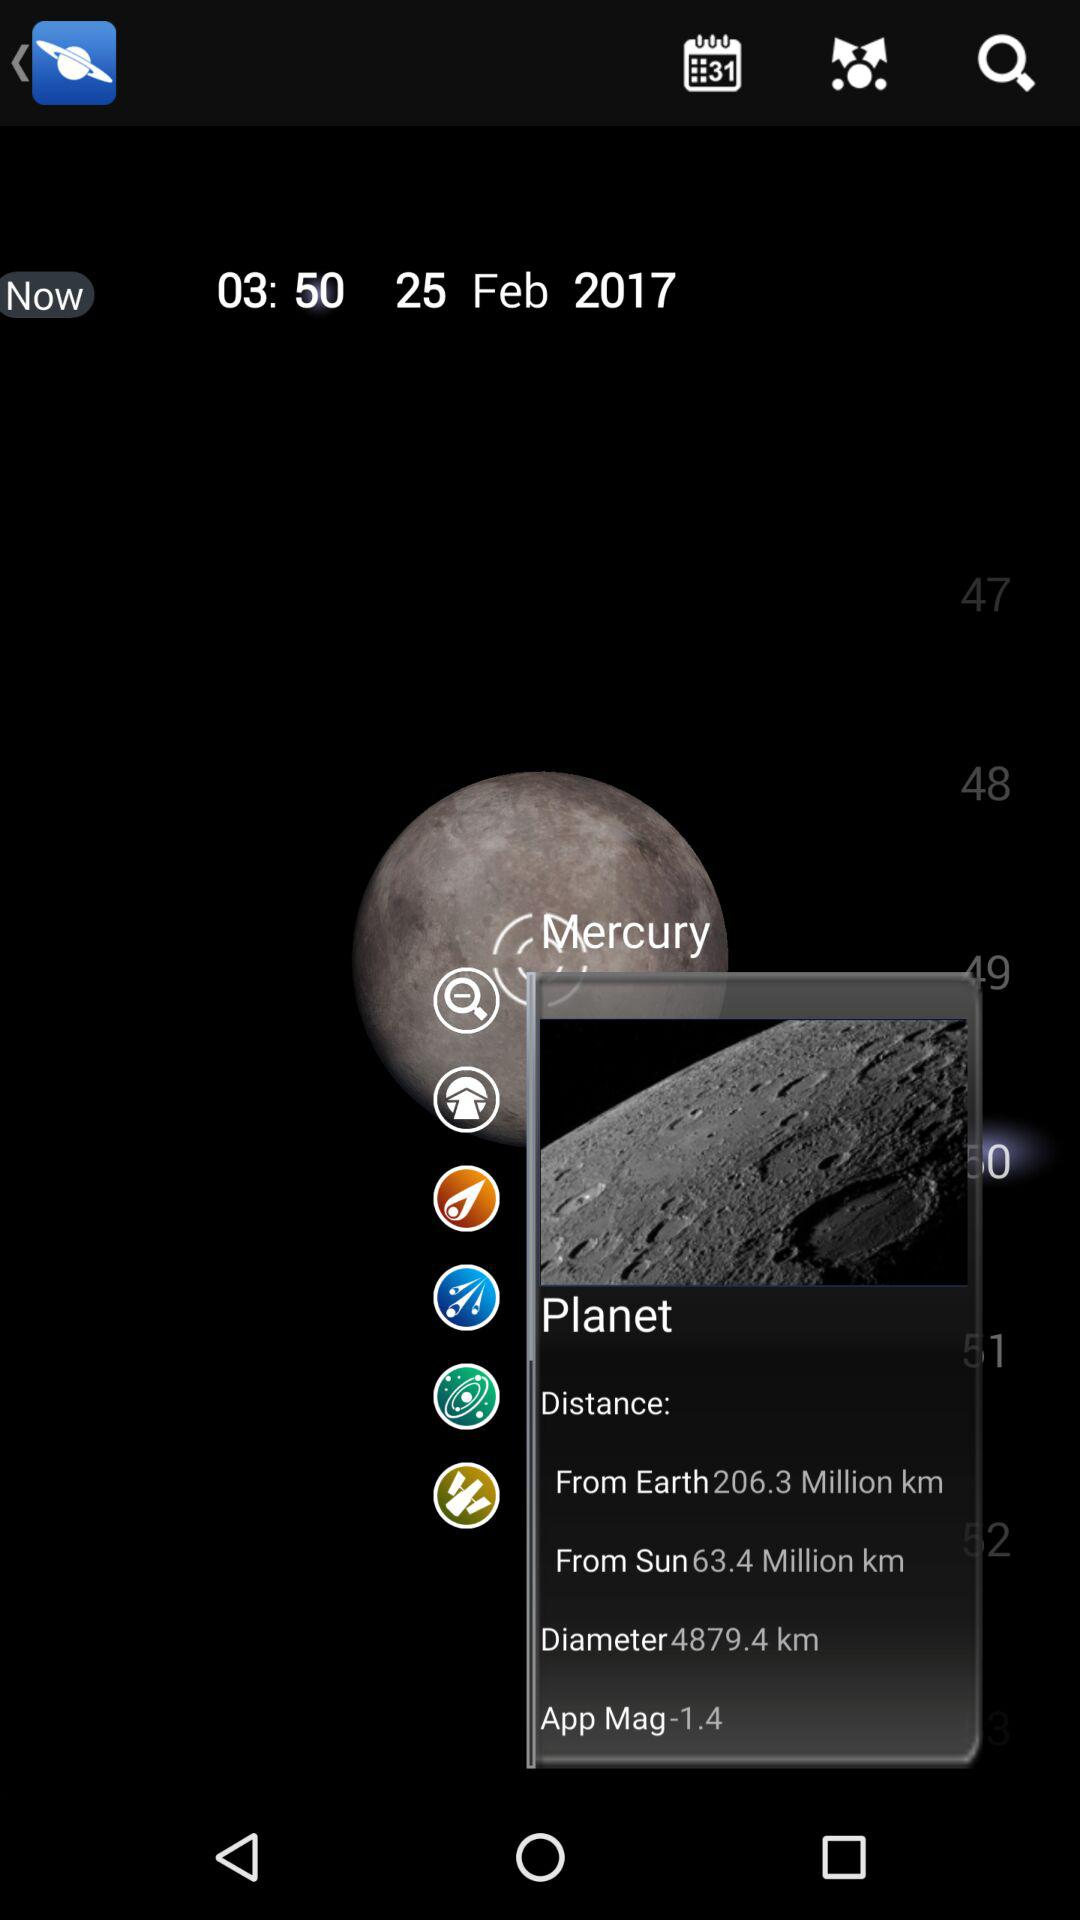What is the diameter of the "Mercury"? The diameter is 4879.4 km. 